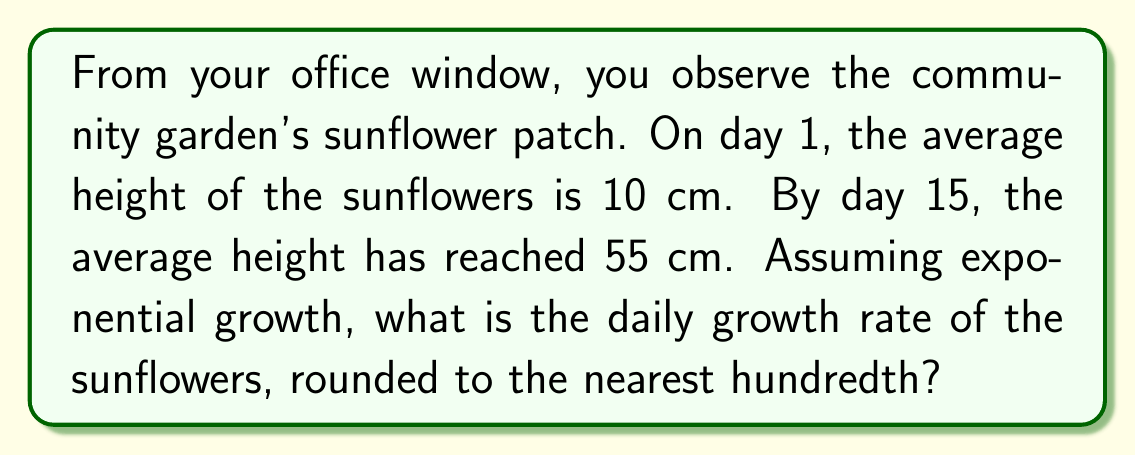Could you help me with this problem? To solve this problem, we'll use the exponential growth formula:

$$A = P(1 + r)^t$$

Where:
$A$ = Final amount (55 cm)
$P$ = Initial amount (10 cm)
$r$ = Daily growth rate (what we're solving for)
$t$ = Time period (15 days)

1) Substitute the known values into the formula:
   $$55 = 10(1 + r)^{15}$$

2) Divide both sides by 10:
   $$5.5 = (1 + r)^{15}$$

3) Take the 15th root of both sides:
   $$\sqrt[15]{5.5} = 1 + r$$

4) Subtract 1 from both sides:
   $$\sqrt[15]{5.5} - 1 = r$$

5) Calculate the value:
   $$r \approx 1.1247 - 1 = 0.1247$$

6) Convert to a percentage and round to the nearest hundredth:
   $$r \approx 12.47\%$$
Answer: 12.47% 